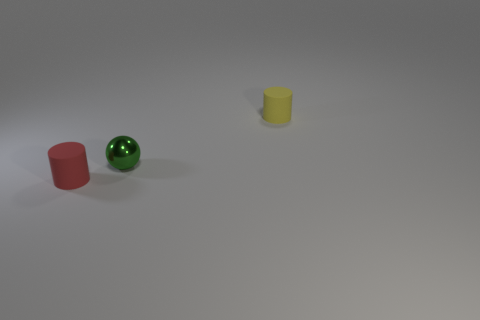Are there the same number of rubber cylinders behind the ball and red cylinders in front of the red cylinder?
Your response must be concise. No. Are any green shiny objects visible?
Ensure brevity in your answer.  Yes. There is a yellow matte object that is the same size as the green ball; what shape is it?
Offer a very short reply. Cylinder. Is there anything else that is the same material as the green thing?
Make the answer very short. No. How many objects are either small matte cylinders behind the tiny metallic sphere or gray rubber things?
Keep it short and to the point. 1. There is a red matte object that is to the left of the rubber object that is behind the small red rubber thing; are there any matte cylinders that are behind it?
Ensure brevity in your answer.  Yes. What number of small gray cubes are there?
Offer a very short reply. 0. How many things are matte cylinders to the left of the shiny ball or small cylinders to the right of the small green ball?
Provide a succinct answer. 2. There is a green thing that is the same size as the red matte cylinder; what material is it?
Keep it short and to the point. Metal. There is another tiny object that is the same shape as the small yellow rubber object; what is it made of?
Offer a terse response. Rubber. 